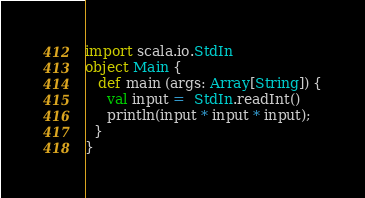Convert code to text. <code><loc_0><loc_0><loc_500><loc_500><_Scala_>import scala.io.StdIn
object Main {
   def main (args: Array[String]) {
     val input =  StdIn.readInt()
     println(input * input * input);
  }
}</code> 